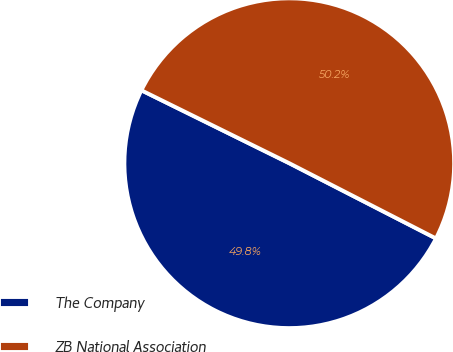Convert chart to OTSL. <chart><loc_0><loc_0><loc_500><loc_500><pie_chart><fcel>The Company<fcel>ZB National Association<nl><fcel>49.75%<fcel>50.25%<nl></chart> 